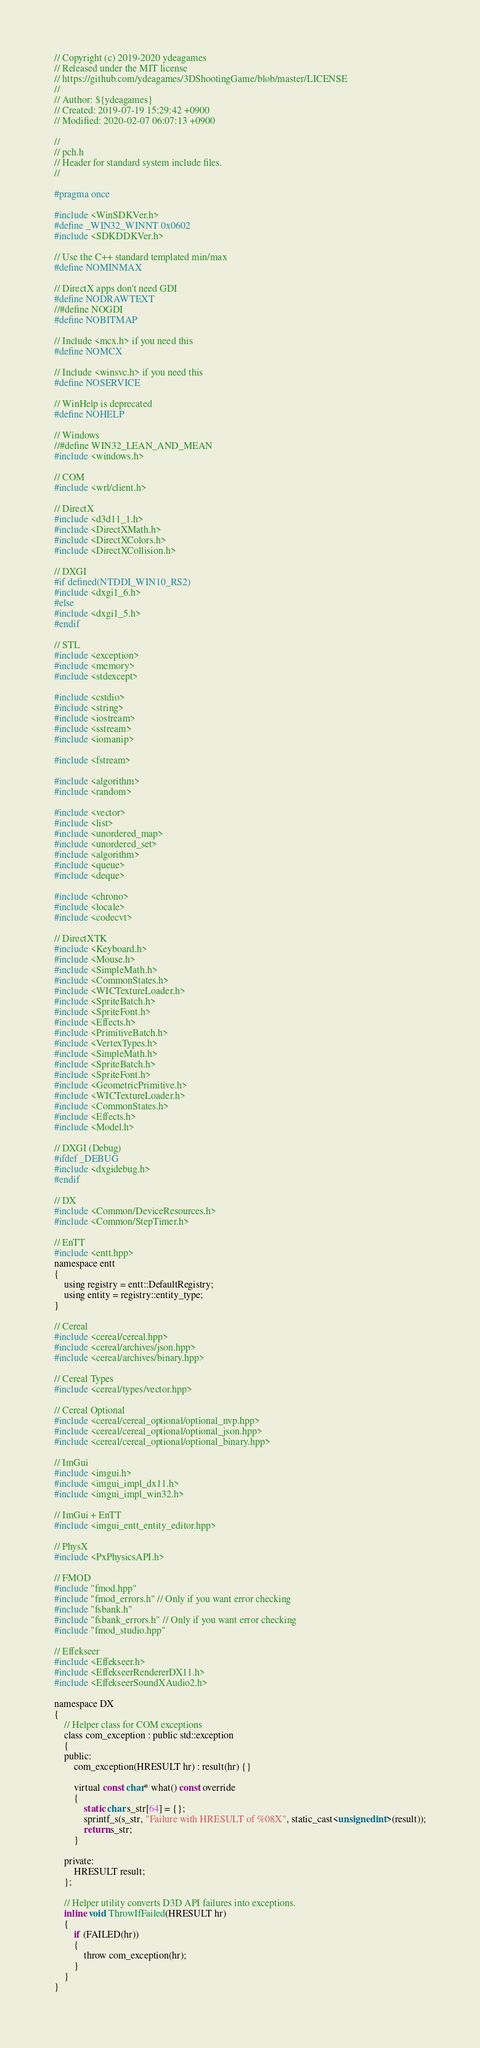Convert code to text. <code><loc_0><loc_0><loc_500><loc_500><_C_>// Copyright (c) 2019-2020 ydeagames
// Released under the MIT license
// https://github.com/ydeagames/3DShootingGame/blob/master/LICENSE
//
// Author: ${ydeagames}
// Created: 2019-07-19 15:29:42 +0900
// Modified: 2020-02-07 06:07:13 +0900

//
// pch.h
// Header for standard system include files.
//

#pragma once

#include <WinSDKVer.h>
#define _WIN32_WINNT 0x0602
#include <SDKDDKVer.h>

// Use the C++ standard templated min/max
#define NOMINMAX

// DirectX apps don't need GDI
#define NODRAWTEXT
//#define NOGDI
#define NOBITMAP

// Include <mcx.h> if you need this
#define NOMCX

// Include <winsvc.h> if you need this
#define NOSERVICE

// WinHelp is deprecated
#define NOHELP

// Windows
//#define WIN32_LEAN_AND_MEAN
#include <windows.h>

// COM
#include <wrl/client.h>

// DirectX
#include <d3d11_1.h>
#include <DirectXMath.h>
#include <DirectXColors.h>
#include <DirectXCollision.h>

// DXGI
#if defined(NTDDI_WIN10_RS2)
#include <dxgi1_6.h>
#else
#include <dxgi1_5.h>
#endif

// STL
#include <exception>
#include <memory>
#include <stdexcept>

#include <cstdio>
#include <string>
#include <iostream>
#include <sstream>
#include <iomanip>

#include <fstream>

#include <algorithm>
#include <random>

#include <vector>
#include <list>
#include <unordered_map>
#include <unordered_set>
#include <algorithm>
#include <queue>
#include <deque>

#include <chrono>
#include <locale> 
#include <codecvt> 

// DirectXTK
#include <Keyboard.h>
#include <Mouse.h>
#include <SimpleMath.h>
#include <CommonStates.h>
#include <WICTextureLoader.h>
#include <SpriteBatch.h>
#include <SpriteFont.h>
#include <Effects.h>
#include <PrimitiveBatch.h>
#include <VertexTypes.h>
#include <SimpleMath.h>
#include <SpriteBatch.h>
#include <SpriteFont.h>
#include <GeometricPrimitive.h>
#include <WICTextureLoader.h>
#include <CommonStates.h>
#include <Effects.h>
#include <Model.h>

// DXGI (Debug)
#ifdef _DEBUG
#include <dxgidebug.h>
#endif

// DX
#include <Common/DeviceResources.h>
#include <Common/StepTimer.h>

// EnTT
#include <entt.hpp>
namespace entt
{
	using registry = entt::DefaultRegistry;
	using entity = registry::entity_type;
}

// Cereal
#include <cereal/cereal.hpp>
#include <cereal/archives/json.hpp>
#include <cereal/archives/binary.hpp>

// Cereal Types
#include <cereal/types/vector.hpp>

// Cereal Optional
#include <cereal/cereal_optional/optional_nvp.hpp>
#include <cereal/cereal_optional/optional_json.hpp>
#include <cereal/cereal_optional/optional_binary.hpp>

// ImGui
#include <imgui.h>
#include <imgui_impl_dx11.h>
#include <imgui_impl_win32.h>

// ImGui + EnTT
#include <imgui_entt_entity_editor.hpp>

// PhysX
#include <PxPhysicsAPI.h>

// FMOD
#include "fmod.hpp"
#include "fmod_errors.h" // Only if you want error checking
#include "fsbank.h"
#include "fsbank_errors.h" // Only if you want error checking
#include "fmod_studio.hpp"

// Effekseer
#include <Effekseer.h>
#include <EffekseerRendererDX11.h>
#include <EffekseerSoundXAudio2.h>

namespace DX
{
	// Helper class for COM exceptions
	class com_exception : public std::exception
	{
	public:
		com_exception(HRESULT hr) : result(hr) {}

		virtual const char* what() const override
		{
            static char s_str[64] = {};
            sprintf_s(s_str, "Failure with HRESULT of %08X", static_cast<unsigned int>(result));
			return s_str;
		}

	private:
		HRESULT result;
	};

	// Helper utility converts D3D API failures into exceptions.
	inline void ThrowIfFailed(HRESULT hr)
	{
		if (FAILED(hr))
		{
			throw com_exception(hr);
		}
	}
}

</code> 